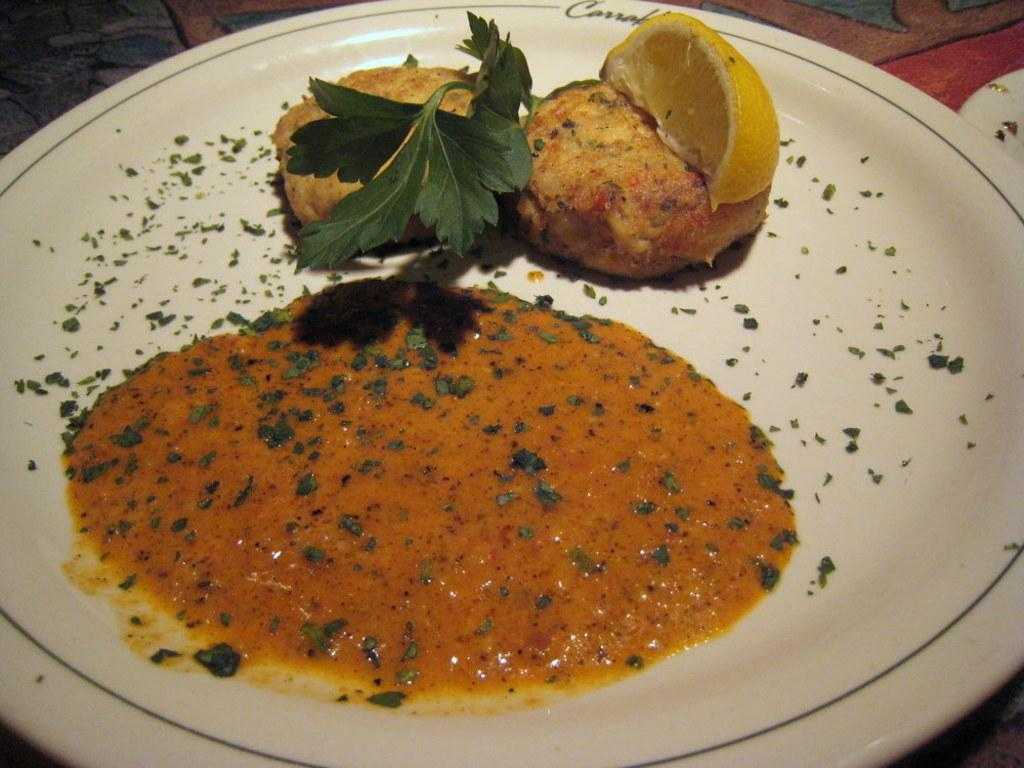What is the color of the plate in the image? The plate in the image is white. What is on the plate? There is food on the plate. Can you describe the colors of the food on the plate? The food has brown, yellow, and red colors. What type of garnish is visible in the image? Coriander leaves are visible in the image. How does the fan help to cool down the food in the image? There is no fan present in the image, so it cannot help to cool down the food. 